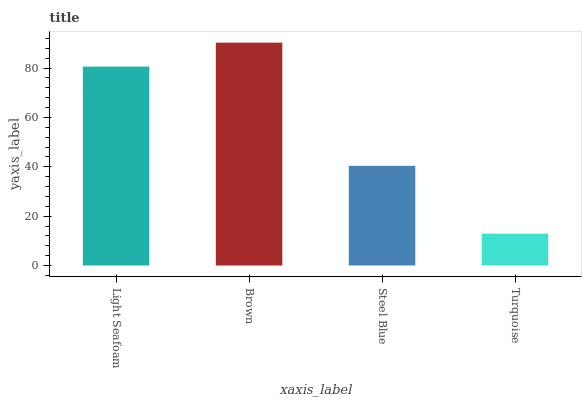Is Turquoise the minimum?
Answer yes or no. Yes. Is Brown the maximum?
Answer yes or no. Yes. Is Steel Blue the minimum?
Answer yes or no. No. Is Steel Blue the maximum?
Answer yes or no. No. Is Brown greater than Steel Blue?
Answer yes or no. Yes. Is Steel Blue less than Brown?
Answer yes or no. Yes. Is Steel Blue greater than Brown?
Answer yes or no. No. Is Brown less than Steel Blue?
Answer yes or no. No. Is Light Seafoam the high median?
Answer yes or no. Yes. Is Steel Blue the low median?
Answer yes or no. Yes. Is Brown the high median?
Answer yes or no. No. Is Brown the low median?
Answer yes or no. No. 